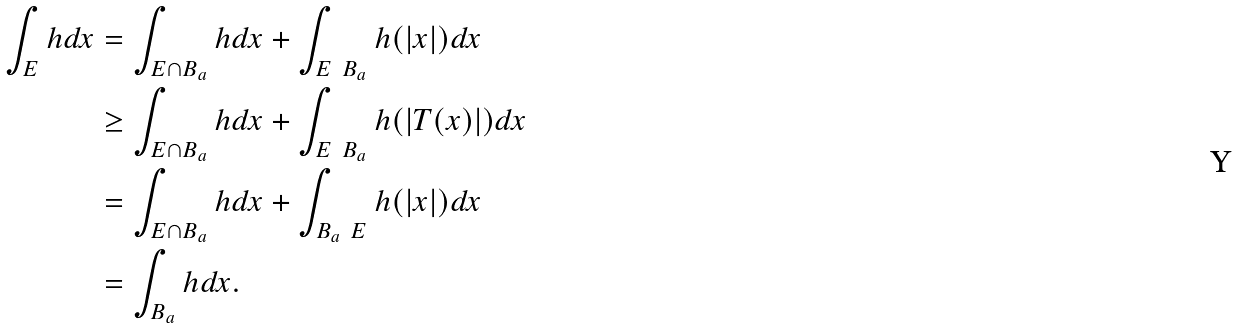Convert formula to latex. <formula><loc_0><loc_0><loc_500><loc_500>\int _ { E } h d x & = \int _ { E \cap B _ { a } } h d x + \int _ { E \ B _ { a } } h ( | x | ) d x \\ & \geq \int _ { E \cap B _ { a } } h d x + \int _ { E \ B _ { a } } h ( | T ( x ) | ) d x \\ & = \int _ { E \cap B _ { a } } h d x + \int _ { B _ { a } \ E } h ( | x | ) d x \\ & = \int _ { B _ { a } } h d x .</formula> 